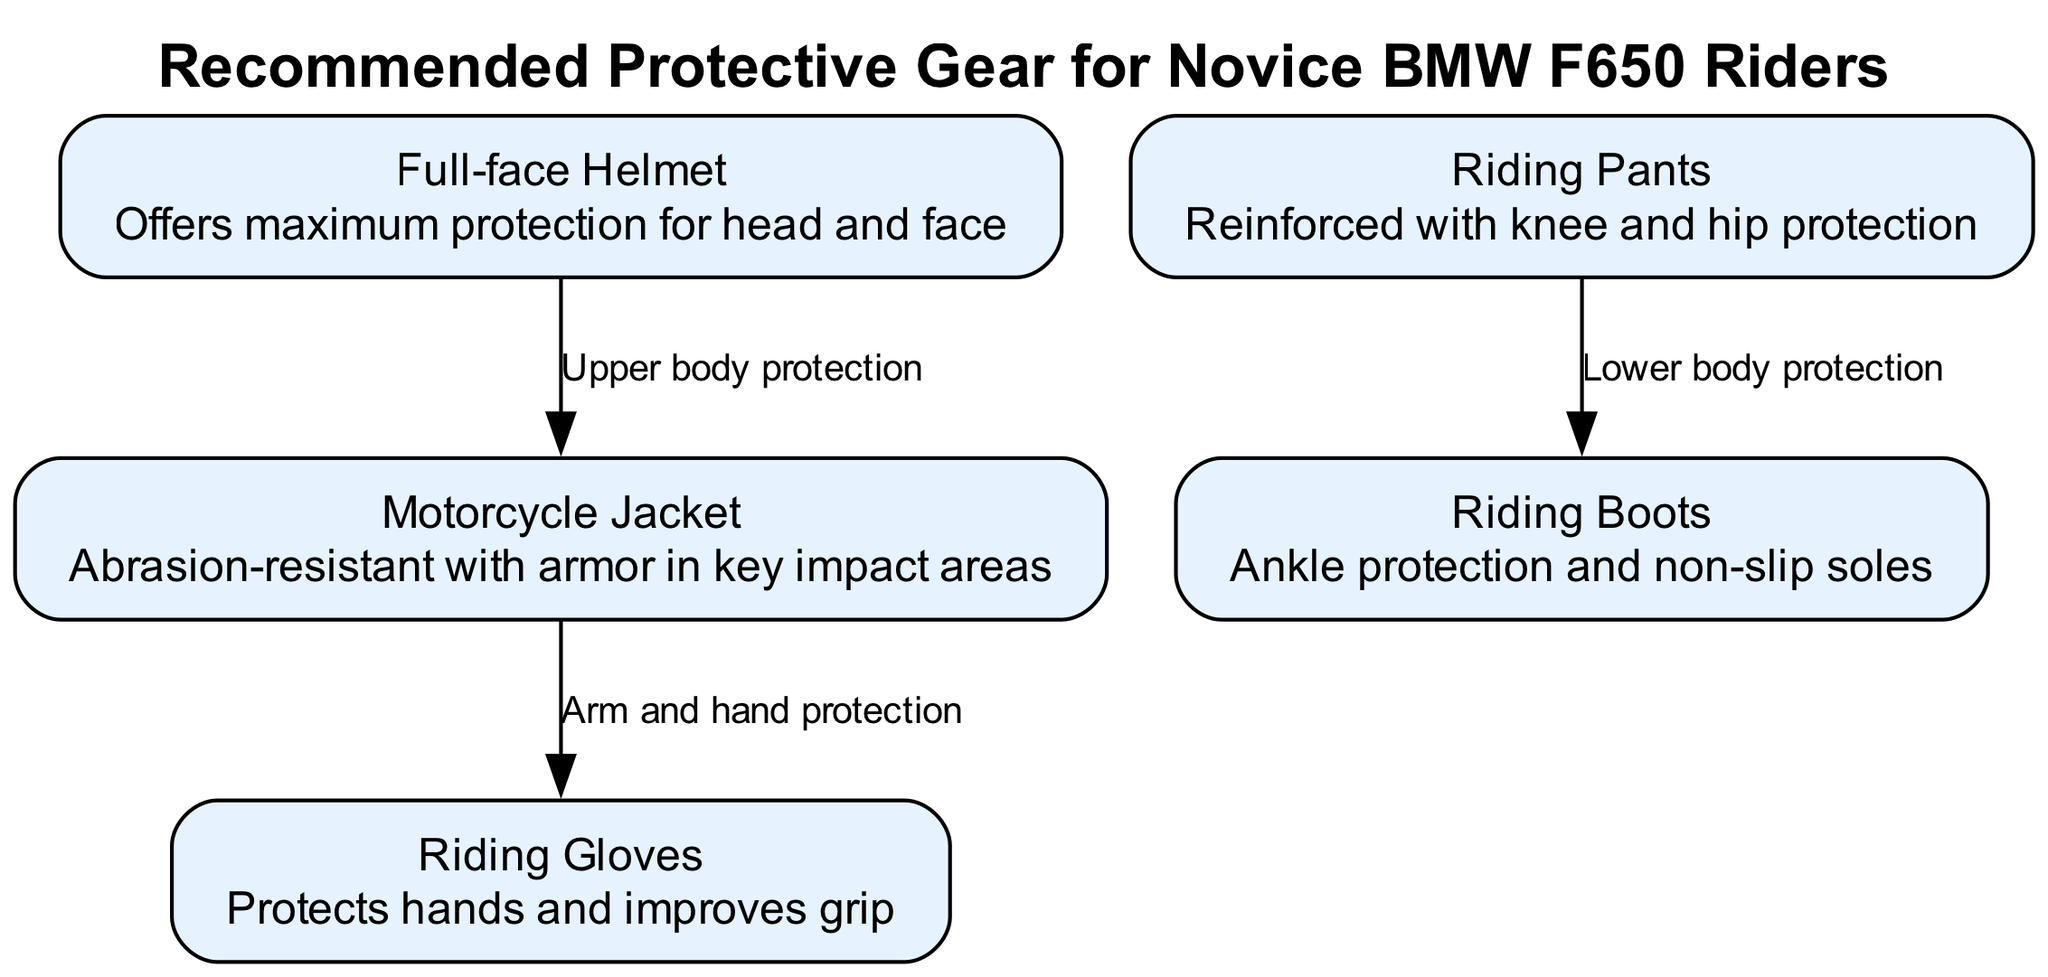What is the first protective gear listed in the diagram? The diagram lists "Full-face Helmet" as the first protective gear under the title "Recommended Protective Gear for Novice BMW F650 Riders." It is the first element in the node list.
Answer: Full-face Helmet How many pieces of protective gear are shown in the diagram? By counting the nodes presented in the diagram, we see there are five distinct pieces of protective gear mentioned: Full-face Helmet, Motorcycle Jacket, Riding Gloves, Riding Boots, and Riding Pants.
Answer: Five What type of protection does the edge between "Full-face Helmet" and "Motorcycle Jacket" indicate? The edge from "Full-face Helmet" to "Motorcycle Jacket" is labeled "Upper body protection," suggesting the protective coverage provided by these two gears together for the upper body.
Answer: Upper body protection What do "Riding Pants" and "Riding Boots" provide protection for? The edge from "Riding Pants" to "Riding Boots" is labeled "Lower body protection," indicating the protection they provide for the lower part of the body.
Answer: Lower body protection Which protective gear is associated with hand protection in the diagram? The "Riding Gloves" node specifically mentions its role in protecting hands and improving grip, clearly indicating it is the gear associated with hand protection.
Answer: Riding Gloves Which gear provides maximum protection for head and face? The "Full-face Helmet" is explicitly described as providing maximum protection for the head and face, making it the gear indicated in the diagram for this purpose.
Answer: Full-face Helmet How does the "Motorcycle Jacket" enhance protection for the arms? The edge linking "Motorcycle Jacket" and "Riding Gloves" is labeled "Arm and hand protection," showing the connection between the jacket's protective features and the gloves, enhancing protection for arms and hands.
Answer: Arm and hand protection What is the relationship between "Riding Pants" and "Riding Boots" according to the diagram? The connection between "Riding Pants" and "Riding Boots" is outlined by the edge labeled "Lower body protection," indicating that both contribute to protection for the lower body.
Answer: Lower body protection Is the "Riding Gloves" gear directly linked to the "Riding Boots" in the diagram? There is no direct edge or connection labeled between "Riding Gloves" and "Riding Boots" in the diagram, meaning they are not directly linked, but are rather connected through other protective gear.
Answer: No 